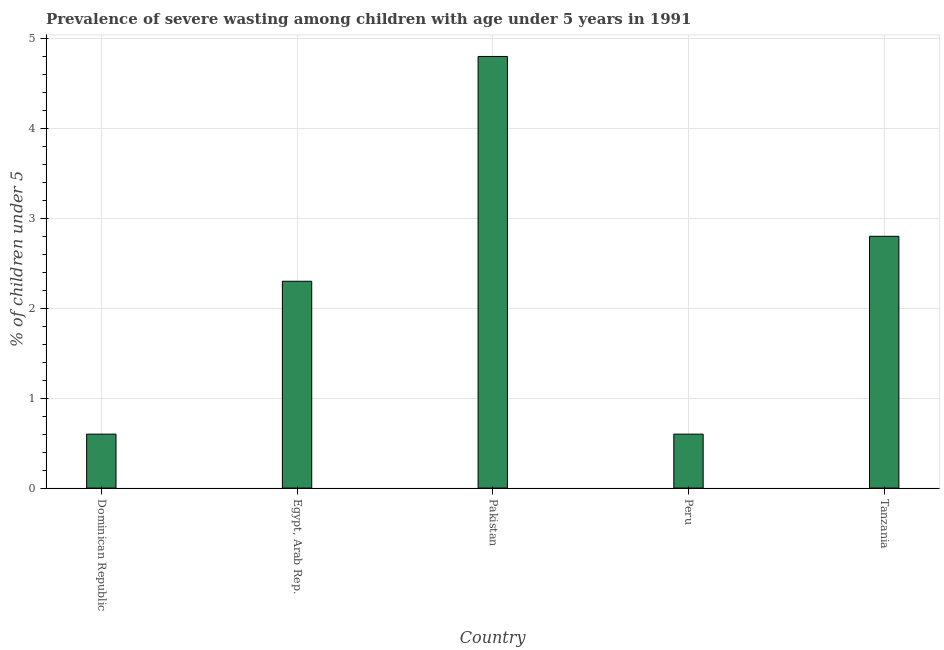What is the title of the graph?
Your answer should be very brief. Prevalence of severe wasting among children with age under 5 years in 1991. What is the label or title of the X-axis?
Make the answer very short. Country. What is the label or title of the Y-axis?
Your answer should be compact.  % of children under 5. What is the prevalence of severe wasting in Tanzania?
Your answer should be compact. 2.8. Across all countries, what is the maximum prevalence of severe wasting?
Your answer should be compact. 4.8. Across all countries, what is the minimum prevalence of severe wasting?
Make the answer very short. 0.6. In which country was the prevalence of severe wasting minimum?
Ensure brevity in your answer.  Dominican Republic. What is the sum of the prevalence of severe wasting?
Your answer should be very brief. 11.1. What is the average prevalence of severe wasting per country?
Offer a very short reply. 2.22. What is the median prevalence of severe wasting?
Keep it short and to the point. 2.3. In how many countries, is the prevalence of severe wasting greater than 1.2 %?
Keep it short and to the point. 3. Is the sum of the prevalence of severe wasting in Dominican Republic and Peru greater than the maximum prevalence of severe wasting across all countries?
Ensure brevity in your answer.  No. In how many countries, is the prevalence of severe wasting greater than the average prevalence of severe wasting taken over all countries?
Provide a short and direct response. 3. How many bars are there?
Make the answer very short. 5. Are all the bars in the graph horizontal?
Give a very brief answer. No. What is the difference between two consecutive major ticks on the Y-axis?
Offer a very short reply. 1. What is the  % of children under 5 in Dominican Republic?
Provide a succinct answer. 0.6. What is the  % of children under 5 in Egypt, Arab Rep.?
Keep it short and to the point. 2.3. What is the  % of children under 5 in Pakistan?
Provide a short and direct response. 4.8. What is the  % of children under 5 of Peru?
Your response must be concise. 0.6. What is the  % of children under 5 in Tanzania?
Make the answer very short. 2.8. What is the difference between the  % of children under 5 in Dominican Republic and Egypt, Arab Rep.?
Offer a very short reply. -1.7. What is the difference between the  % of children under 5 in Dominican Republic and Tanzania?
Ensure brevity in your answer.  -2.2. What is the difference between the  % of children under 5 in Egypt, Arab Rep. and Tanzania?
Your response must be concise. -0.5. What is the difference between the  % of children under 5 in Pakistan and Peru?
Provide a short and direct response. 4.2. What is the difference between the  % of children under 5 in Pakistan and Tanzania?
Make the answer very short. 2. What is the difference between the  % of children under 5 in Peru and Tanzania?
Ensure brevity in your answer.  -2.2. What is the ratio of the  % of children under 5 in Dominican Republic to that in Egypt, Arab Rep.?
Your response must be concise. 0.26. What is the ratio of the  % of children under 5 in Dominican Republic to that in Tanzania?
Ensure brevity in your answer.  0.21. What is the ratio of the  % of children under 5 in Egypt, Arab Rep. to that in Pakistan?
Your response must be concise. 0.48. What is the ratio of the  % of children under 5 in Egypt, Arab Rep. to that in Peru?
Ensure brevity in your answer.  3.83. What is the ratio of the  % of children under 5 in Egypt, Arab Rep. to that in Tanzania?
Ensure brevity in your answer.  0.82. What is the ratio of the  % of children under 5 in Pakistan to that in Tanzania?
Your response must be concise. 1.71. What is the ratio of the  % of children under 5 in Peru to that in Tanzania?
Offer a very short reply. 0.21. 